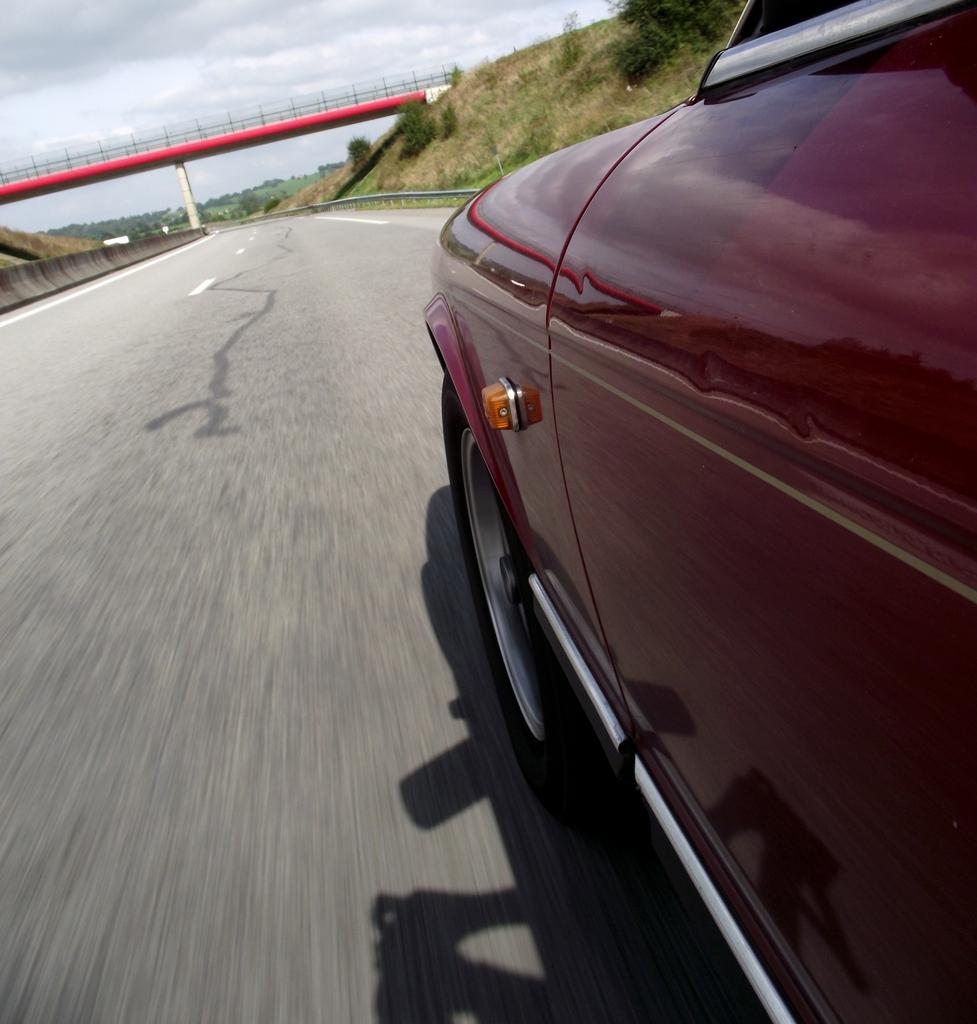What is the main subject of the image? There is a car on the road in the image. What structure can be seen in the image? There is a bridge in the image. What type of vegetation is present in the image? There are plants and trees in the image. What part of the natural environment is visible in the image? The sky is visible in the image. What type of mist can be seen surrounding the car in the image? There is no mist present in the image; the car is on a road with clear visibility. 